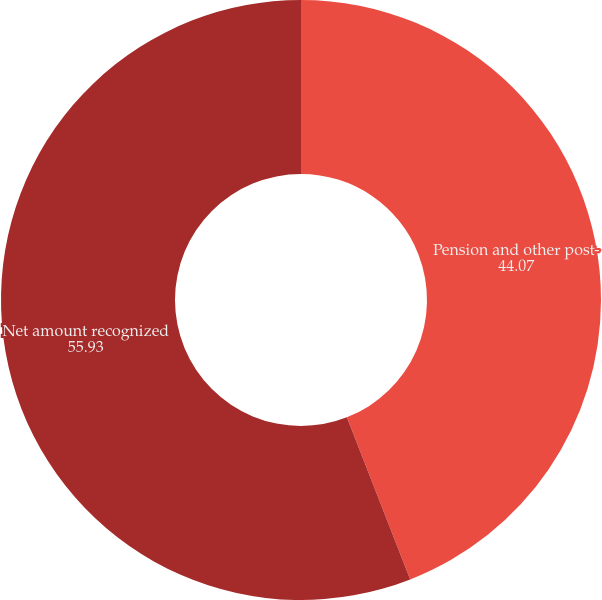<chart> <loc_0><loc_0><loc_500><loc_500><pie_chart><fcel>Pension and other post-<fcel>Net amount recognized<nl><fcel>44.07%<fcel>55.93%<nl></chart> 